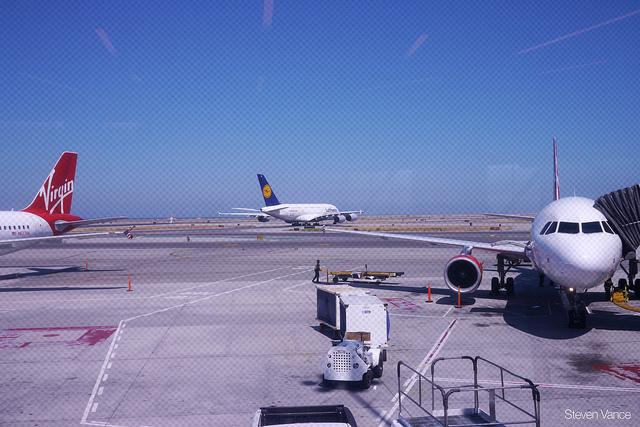What color is the tail fin on the furthest left side of the tarmac? red 